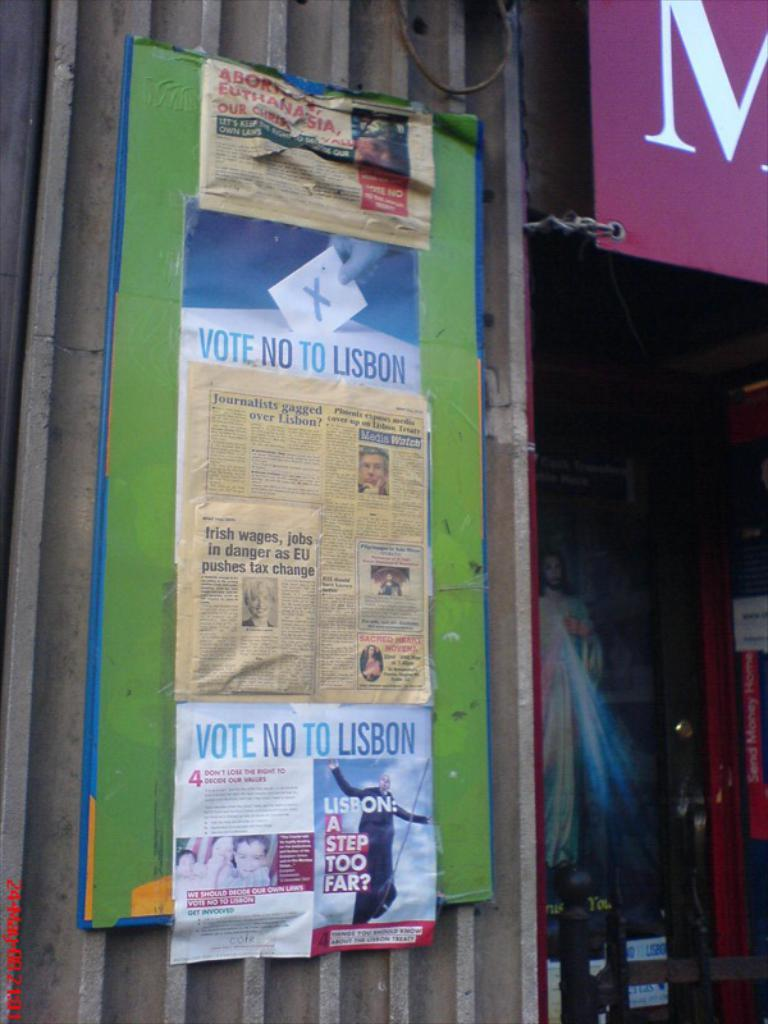<image>
Offer a succinct explanation of the picture presented. A flyer on a bulletin board outside a store that says Vote No To Lisbon on it. 